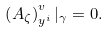<formula> <loc_0><loc_0><loc_500><loc_500>\left ( A _ { \zeta } \right ) ^ { v } _ { y ^ { i } } | _ { \gamma } = 0 .</formula> 